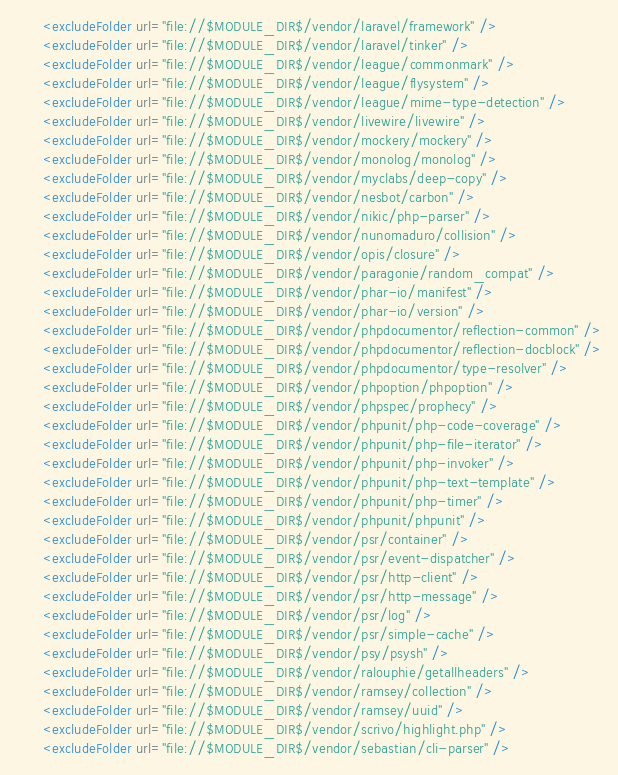Convert code to text. <code><loc_0><loc_0><loc_500><loc_500><_XML_>      <excludeFolder url="file://$MODULE_DIR$/vendor/laravel/framework" />
      <excludeFolder url="file://$MODULE_DIR$/vendor/laravel/tinker" />
      <excludeFolder url="file://$MODULE_DIR$/vendor/league/commonmark" />
      <excludeFolder url="file://$MODULE_DIR$/vendor/league/flysystem" />
      <excludeFolder url="file://$MODULE_DIR$/vendor/league/mime-type-detection" />
      <excludeFolder url="file://$MODULE_DIR$/vendor/livewire/livewire" />
      <excludeFolder url="file://$MODULE_DIR$/vendor/mockery/mockery" />
      <excludeFolder url="file://$MODULE_DIR$/vendor/monolog/monolog" />
      <excludeFolder url="file://$MODULE_DIR$/vendor/myclabs/deep-copy" />
      <excludeFolder url="file://$MODULE_DIR$/vendor/nesbot/carbon" />
      <excludeFolder url="file://$MODULE_DIR$/vendor/nikic/php-parser" />
      <excludeFolder url="file://$MODULE_DIR$/vendor/nunomaduro/collision" />
      <excludeFolder url="file://$MODULE_DIR$/vendor/opis/closure" />
      <excludeFolder url="file://$MODULE_DIR$/vendor/paragonie/random_compat" />
      <excludeFolder url="file://$MODULE_DIR$/vendor/phar-io/manifest" />
      <excludeFolder url="file://$MODULE_DIR$/vendor/phar-io/version" />
      <excludeFolder url="file://$MODULE_DIR$/vendor/phpdocumentor/reflection-common" />
      <excludeFolder url="file://$MODULE_DIR$/vendor/phpdocumentor/reflection-docblock" />
      <excludeFolder url="file://$MODULE_DIR$/vendor/phpdocumentor/type-resolver" />
      <excludeFolder url="file://$MODULE_DIR$/vendor/phpoption/phpoption" />
      <excludeFolder url="file://$MODULE_DIR$/vendor/phpspec/prophecy" />
      <excludeFolder url="file://$MODULE_DIR$/vendor/phpunit/php-code-coverage" />
      <excludeFolder url="file://$MODULE_DIR$/vendor/phpunit/php-file-iterator" />
      <excludeFolder url="file://$MODULE_DIR$/vendor/phpunit/php-invoker" />
      <excludeFolder url="file://$MODULE_DIR$/vendor/phpunit/php-text-template" />
      <excludeFolder url="file://$MODULE_DIR$/vendor/phpunit/php-timer" />
      <excludeFolder url="file://$MODULE_DIR$/vendor/phpunit/phpunit" />
      <excludeFolder url="file://$MODULE_DIR$/vendor/psr/container" />
      <excludeFolder url="file://$MODULE_DIR$/vendor/psr/event-dispatcher" />
      <excludeFolder url="file://$MODULE_DIR$/vendor/psr/http-client" />
      <excludeFolder url="file://$MODULE_DIR$/vendor/psr/http-message" />
      <excludeFolder url="file://$MODULE_DIR$/vendor/psr/log" />
      <excludeFolder url="file://$MODULE_DIR$/vendor/psr/simple-cache" />
      <excludeFolder url="file://$MODULE_DIR$/vendor/psy/psysh" />
      <excludeFolder url="file://$MODULE_DIR$/vendor/ralouphie/getallheaders" />
      <excludeFolder url="file://$MODULE_DIR$/vendor/ramsey/collection" />
      <excludeFolder url="file://$MODULE_DIR$/vendor/ramsey/uuid" />
      <excludeFolder url="file://$MODULE_DIR$/vendor/scrivo/highlight.php" />
      <excludeFolder url="file://$MODULE_DIR$/vendor/sebastian/cli-parser" /></code> 